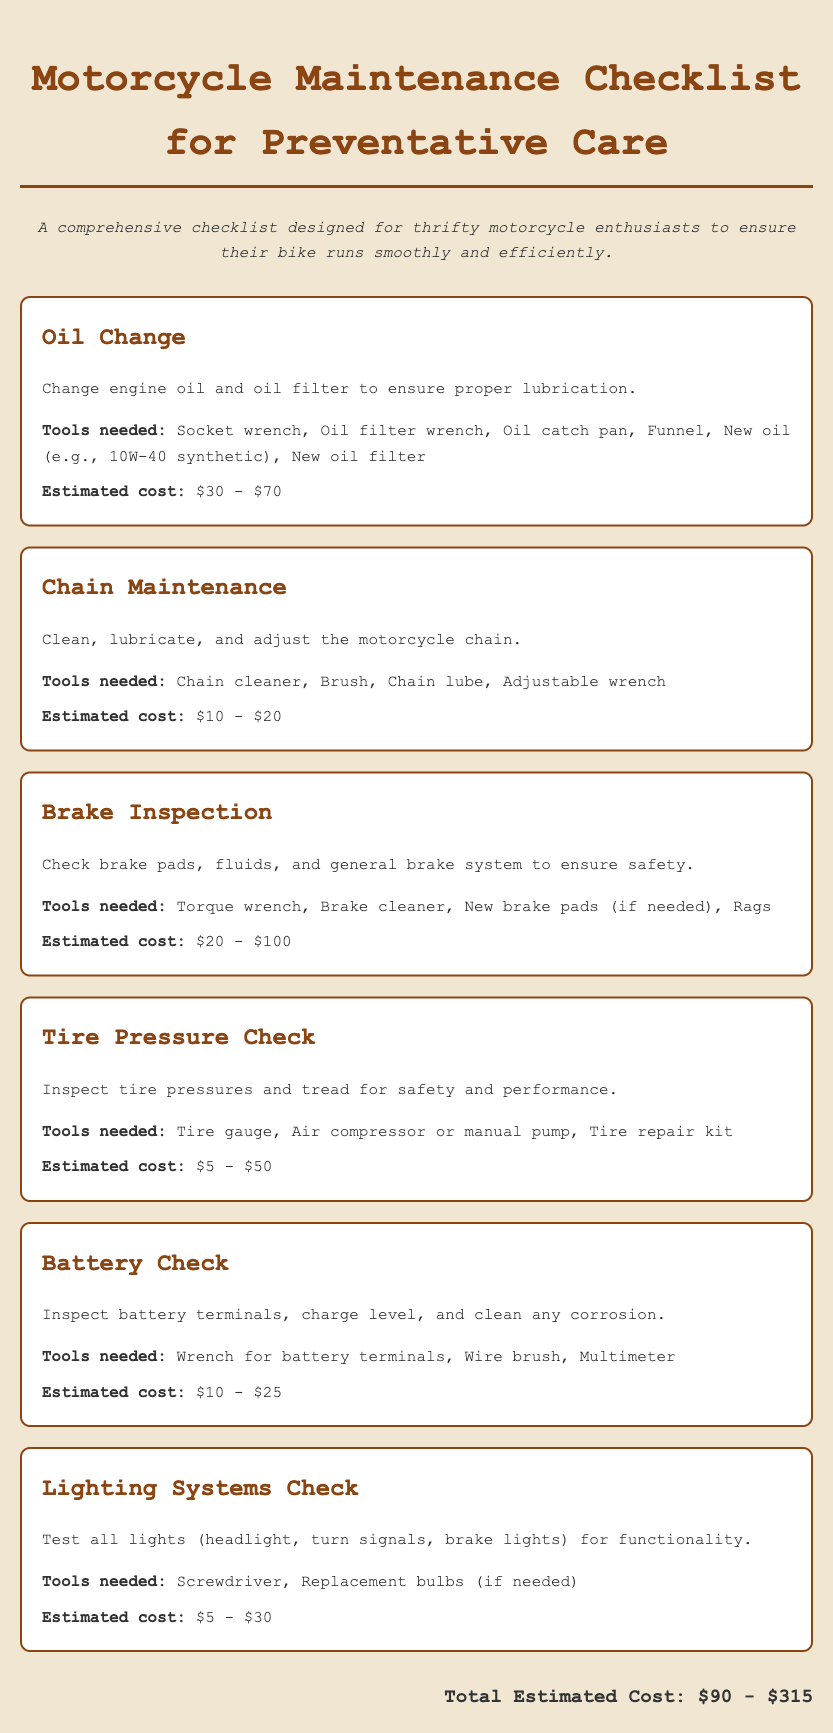What is the first task in the checklist? The first task listed in the checklist, as seen at the beginning of the document, is "Oil Change."
Answer: Oil Change What tools are needed for brake inspection? The tools needed for brake inspection are detailed in the specific task section, which includes a torque wrench and brake cleaner.
Answer: Torque wrench, Brake cleaner, New brake pads, Rags What is the estimated cost range for tire pressure checks? The estimated cost for checking tire pressure is found in its corresponding task section.
Answer: $5 - $50 How many tasks are listed in the document? The number of distinct tasks provided can be counted from the section titles in the document.
Answer: Six What is the total estimated cost of all maintenance tasks? The total estimated cost is summarized at the end of the document, combining the individual costs of all tasks.
Answer: $90 - $315 Which task requires a multimeter? The task requiring a multimeter is identified within the descriptions of the specific tasks in the document.
Answer: Battery Check What is the purpose of the oil change task? The purpose of the oil change task is stated clearly in its description, focusing on lubrication.
Answer: Proper lubrication Which task includes adjusting the motorcycle chain? The task that involves adjusting the motorcycle chain is explicitly mentioned in the title and description of that task.
Answer: Chain Maintenance 